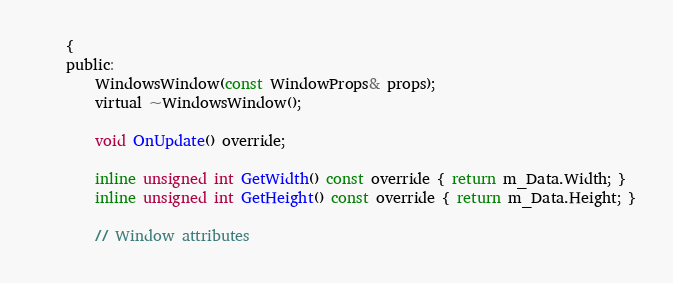<code> <loc_0><loc_0><loc_500><loc_500><_C_>	{
	public:
		WindowsWindow(const WindowProps& props);
		virtual ~WindowsWindow();

		void OnUpdate() override;

		inline unsigned int GetWidth() const override { return m_Data.Width; }
		inline unsigned int GetHeight() const override { return m_Data.Height; }

		// Window attributes</code> 